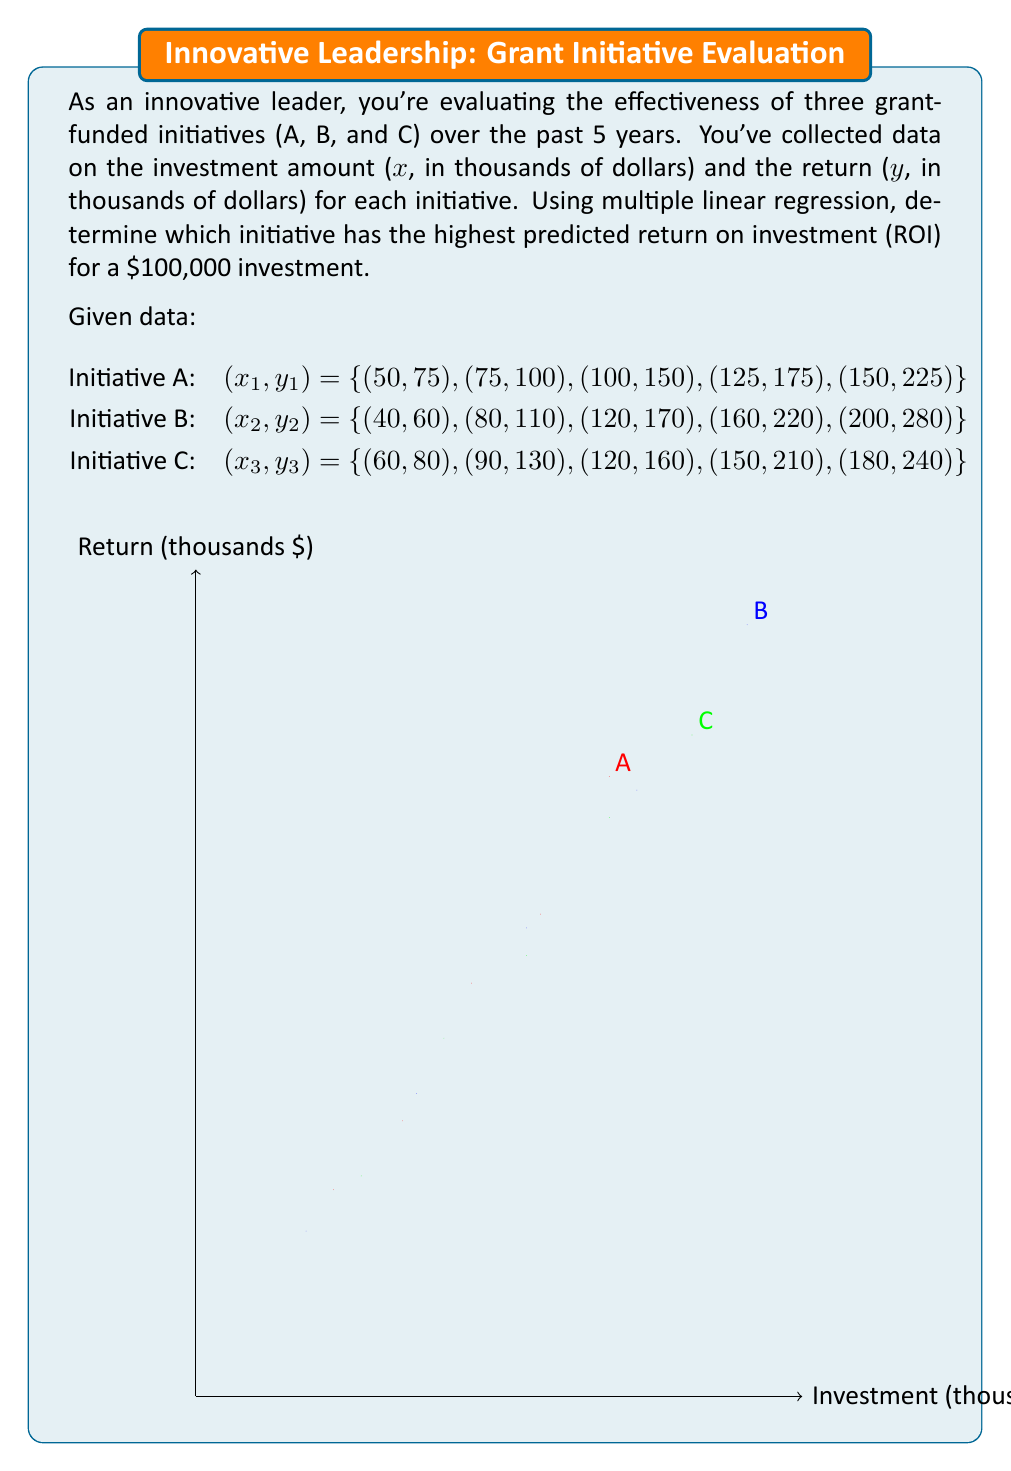What is the answer to this math problem? To solve this problem, we need to follow these steps:

1. Calculate the linear regression equation for each initiative.
2. Use the equations to predict the return for a $100,000 investment.
3. Calculate the ROI for each initiative and compare.

Step 1: Linear Regression Equations

For each initiative, we'll use the formula:
$$y = mx + b$$
where m is the slope and b is the y-intercept.

Using the least squares method, we can calculate m and b:

$$m = \frac{n\sum xy - \sum x \sum y}{n\sum x^2 - (\sum x)^2}$$
$$b = \frac{\sum y - m\sum x}{n}$$

Initiative A:
$$m_A = 1.5, b_A = -0.5$$
$$y_A = 1.5x - 0.5$$

Initiative B:
$$m_B = 1.375, b_B = 5$$
$$y_B = 1.375x + 5$$

Initiative C:
$$m_C = 1.3333, b_C = 0$$
$$y_C = 1.3333x$$

Step 2: Predict Return for $100,000 Investment

For x = 100 (as we're working in thousands):

Initiative A: $y_A = 1.5(100) - 0.5 = 149.5$
Initiative B: $y_B = 1.375(100) + 5 = 142.5$
Initiative C: $y_C = 1.3333(100) = 133.33$

Step 3: Calculate and Compare ROI

ROI = (Return - Investment) / Investment

Initiative A: $ROI_A = (149.5 - 100) / 100 = 0.495 = 49.5\%$
Initiative B: $ROI_B = (142.5 - 100) / 100 = 0.425 = 42.5\%$
Initiative C: $ROI_C = (133.33 - 100) / 100 = 0.3333 = 33.33\%$

Initiative A has the highest predicted ROI for a $100,000 investment.
Answer: Initiative A (49.5% ROI) 